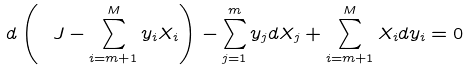<formula> <loc_0><loc_0><loc_500><loc_500>d \left ( \ J - \sum _ { i = m + 1 } ^ { M } y _ { i } X _ { i } \right ) - \sum _ { j = 1 } ^ { m } y _ { j } d X _ { j } + \sum _ { i = m + 1 } ^ { M } X _ { i } d y _ { i } = 0</formula> 